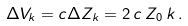Convert formula to latex. <formula><loc_0><loc_0><loc_500><loc_500>\Delta { V } _ { k } = c \Delta { Z } _ { k } = 2 \, c \, Z _ { 0 } \, k \, .</formula> 